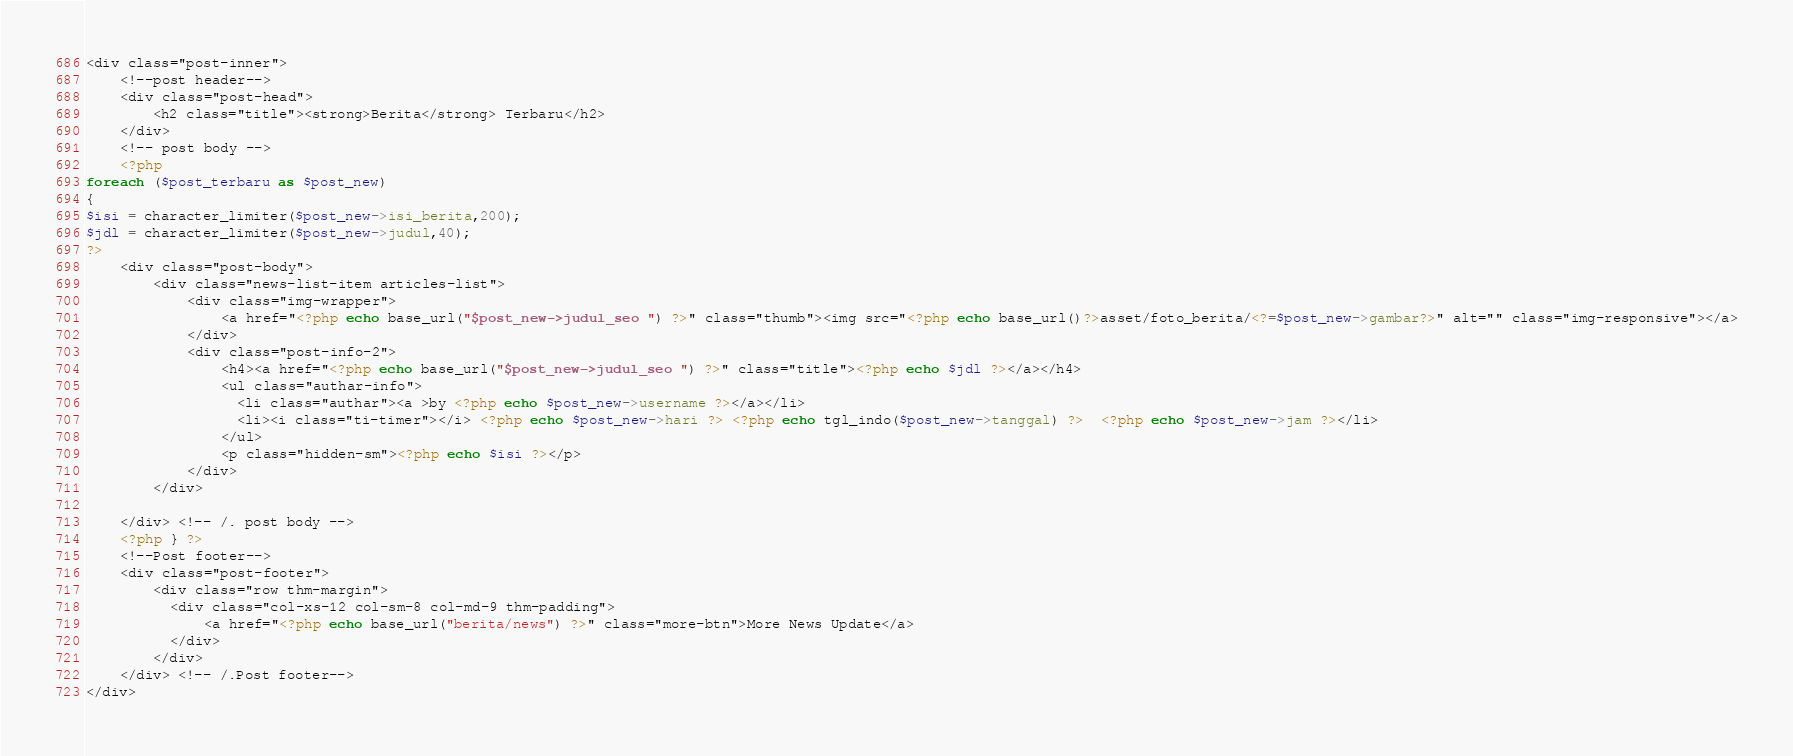Convert code to text. <code><loc_0><loc_0><loc_500><loc_500><_PHP_><div class="post-inner">
    <!--post header-->
    <div class="post-head">
        <h2 class="title"><strong>Berita</strong> Terbaru</h2>
    </div>
    <!-- post body -->
    <?php
foreach ($post_terbaru as $post_new)
{
$isi = character_limiter($post_new->isi_berita,200);
$jdl = character_limiter($post_new->judul,40);
?>
    <div class="post-body">
        <div class="news-list-item articles-list">
            <div class="img-wrapper">
                <a href="<?php echo base_url("$post_new->judul_seo ") ?>" class="thumb"><img src="<?php echo base_url()?>asset/foto_berita/<?=$post_new->gambar?>" alt="" class="img-responsive"></a>
            </div>
            <div class="post-info-2">
                <h4><a href="<?php echo base_url("$post_new->judul_seo ") ?>" class="title"><?php echo $jdl ?></a></h4>
                <ul class="authar-info">
                  <li class="authar"><a >by <?php echo $post_new->username ?></a></li>
                  <li><i class="ti-timer"></i> <?php echo $post_new->hari ?> <?php echo tgl_indo($post_new->tanggal) ?>  <?php echo $post_new->jam ?></li>
                </ul>
                <p class="hidden-sm"><?php echo $isi ?></p>
            </div>
        </div>

    </div> <!-- /. post body -->
    <?php } ?>
    <!--Post footer-->
    <div class="post-footer">
        <div class="row thm-margin">
          <div class="col-xs-12 col-sm-8 col-md-9 thm-padding">
              <a href="<?php echo base_url("berita/news") ?>" class="more-btn">More News Update</a>
          </div>
        </div>
    </div> <!-- /.Post footer-->
</div>
</code> 